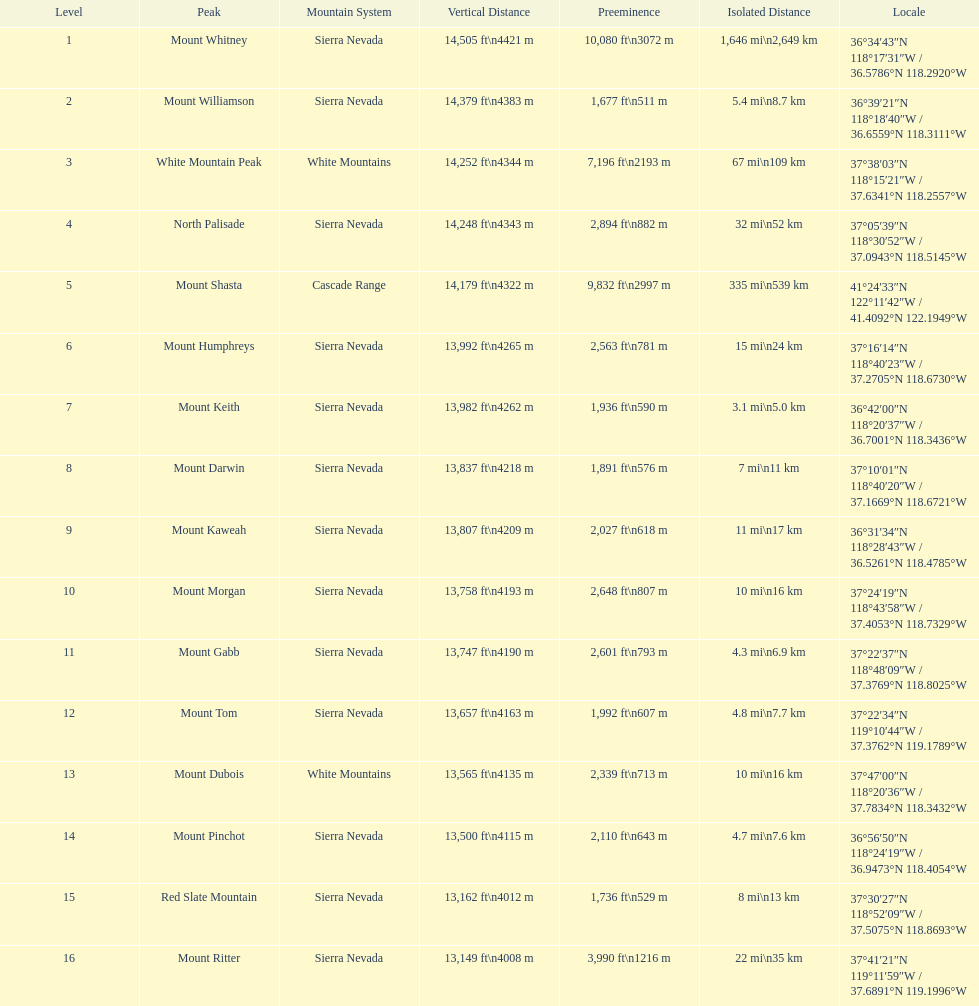Which mountain peak has a prominence more than 10,000 ft? Mount Whitney. 